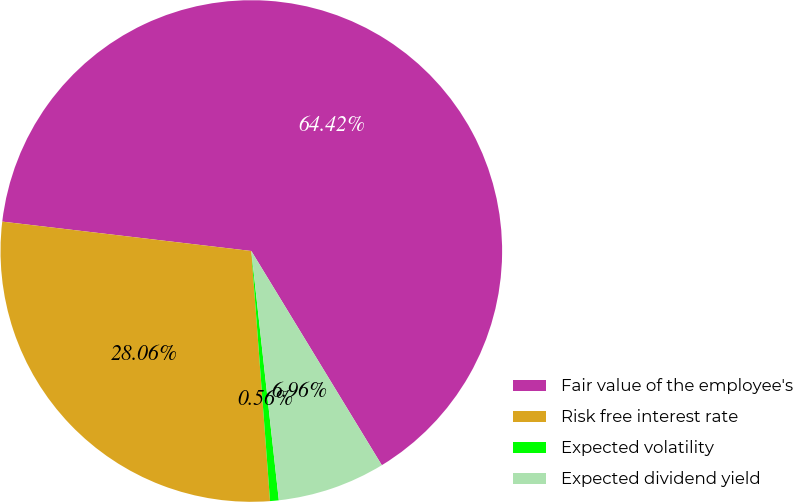Convert chart. <chart><loc_0><loc_0><loc_500><loc_500><pie_chart><fcel>Fair value of the employee's<fcel>Risk free interest rate<fcel>Expected volatility<fcel>Expected dividend yield<nl><fcel>64.42%<fcel>28.06%<fcel>0.56%<fcel>6.96%<nl></chart> 